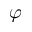<formula> <loc_0><loc_0><loc_500><loc_500>\varphi</formula> 